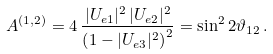<formula> <loc_0><loc_0><loc_500><loc_500>A ^ { ( 1 , 2 ) } = 4 \, \frac { | U _ { e 1 } | ^ { 2 } \, | U _ { e 2 } | ^ { 2 } } { \left ( 1 - | U _ { e 3 } | ^ { 2 } \right ) ^ { 2 } } = \sin ^ { 2 } 2 \vartheta _ { 1 2 } \, .</formula> 